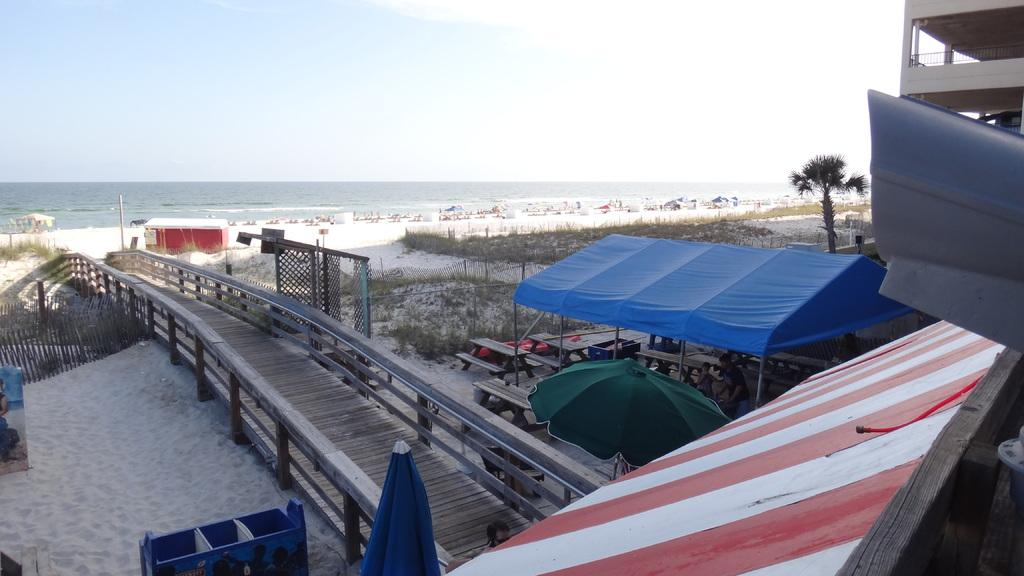What type of structure can be seen in the image? There is a small bridge in the image. What type of temporary shelters are present in the image? There are tents in the image. What type of furniture is visible in the image? There are tables in the image. What type of objects can be found in the sand in the image? There are other objects in the sand in the image. What type of vegetation is present in the image? There is grass in the image. What type of tree is visible in the image? There is a tree in the image. What type of large body of water is visible in the image? The ocean is visible in the image. What is the condition of the sky in the image? The sky is clear in the image. How many representatives are present in the image? There is no mention of representatives in the image; it features a small bridge, tents, tables, objects in the sand, grass, a tree, the ocean, and a clear sky. Can you describe the person pushing the tree in the image? There is no person pushing the tree in the image; it features a small bridge, tents, tables, objects in the sand, grass, a tree, the ocean, and a clear sky. 